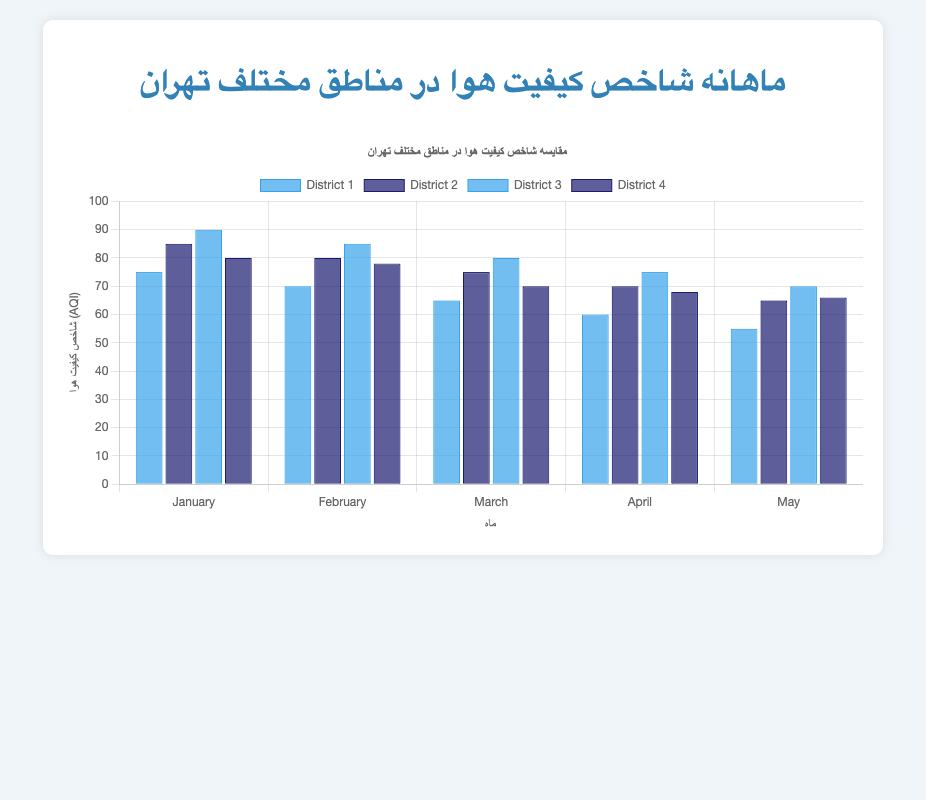What is the average AQI for District 1 in the given months? First, sum up the AQI values for District 1 across the months: 75 (January) + 70 (February) + 65 (March) + 60 (April) + 55 (May) = 325. Then divide by the number of months, which is 5. So, 325 / 5 = 65
Answer: 65 Which district had the highest AQI in January? In January, compare the AQI values across District 1 (75), District 2 (85), District 3 (90), and District 4 (80). District 3 has the highest AQI of 90.
Answer: District 3 How does the AQI of District 2 in February compare to District 4 in February? In February, the AQI of District 2 is 80 and the AQI of District 4 is 78. Comparing the two, District 2 has a higher AQI than District 4.
Answer: District 2 has a higher AQI Which month showed the lowest AQI for District 3? Check the AQI values for District 3 across the months: January (90), February (85), March (80), April (75), and May (70). The lowest AQI is in May, which is 70.
Answer: May What is the difference between the highest and lowest AQI for District 4 across all months? Find the highest and lowest AQI for District 4: the highest is in January (80), and the lowest is in April (68). Subtract the lowest from the highest: 80 - 68 = 12
Answer: 12 In which month did all districts have their AQI lower than 80? Check each month's AQI: January (District 3 has 90, so not this month), February (District 3 has 85, so not this month), March (District 3 has 80, so not this month), April (all AQIs are below 80: District 1 - 60, District 2 - 70, District 3 - 75, District 4 - 68), and May (all AQIs are below 80: District 1 - 55, District 2 - 65, District 3 - 70, District 4 - 66). So, both April and May qualify.
Answer: April, May Compare the overall trend of AQI for District 1 and District 4 from January to May. For District 1, AQI decreases from January (75) to May (55). For District 4, AQI also shows a decrease from January (80) to May (66). Both districts show a downward trend.
Answer: Both show a downward trend Which district had the most significant decrease in AQI from January to May? Calculate the decrease for each district: District 1 (75-55=20), District 2 (85-65=20), District 3 (90-70=20), and District 4 (80-66=14). District 1, District 2, and District 3 each decreased by 20, the most significant decrease.
Answer: District 1, District 2, District 3 Which district has the most consistently high AQI throughout the months? Check the AQI values over the months. District 3 consistently has high values: January (90), February (85), March (80), April (75), and May (70). Other districts have lower values or more significant drops.
Answer: District 3 